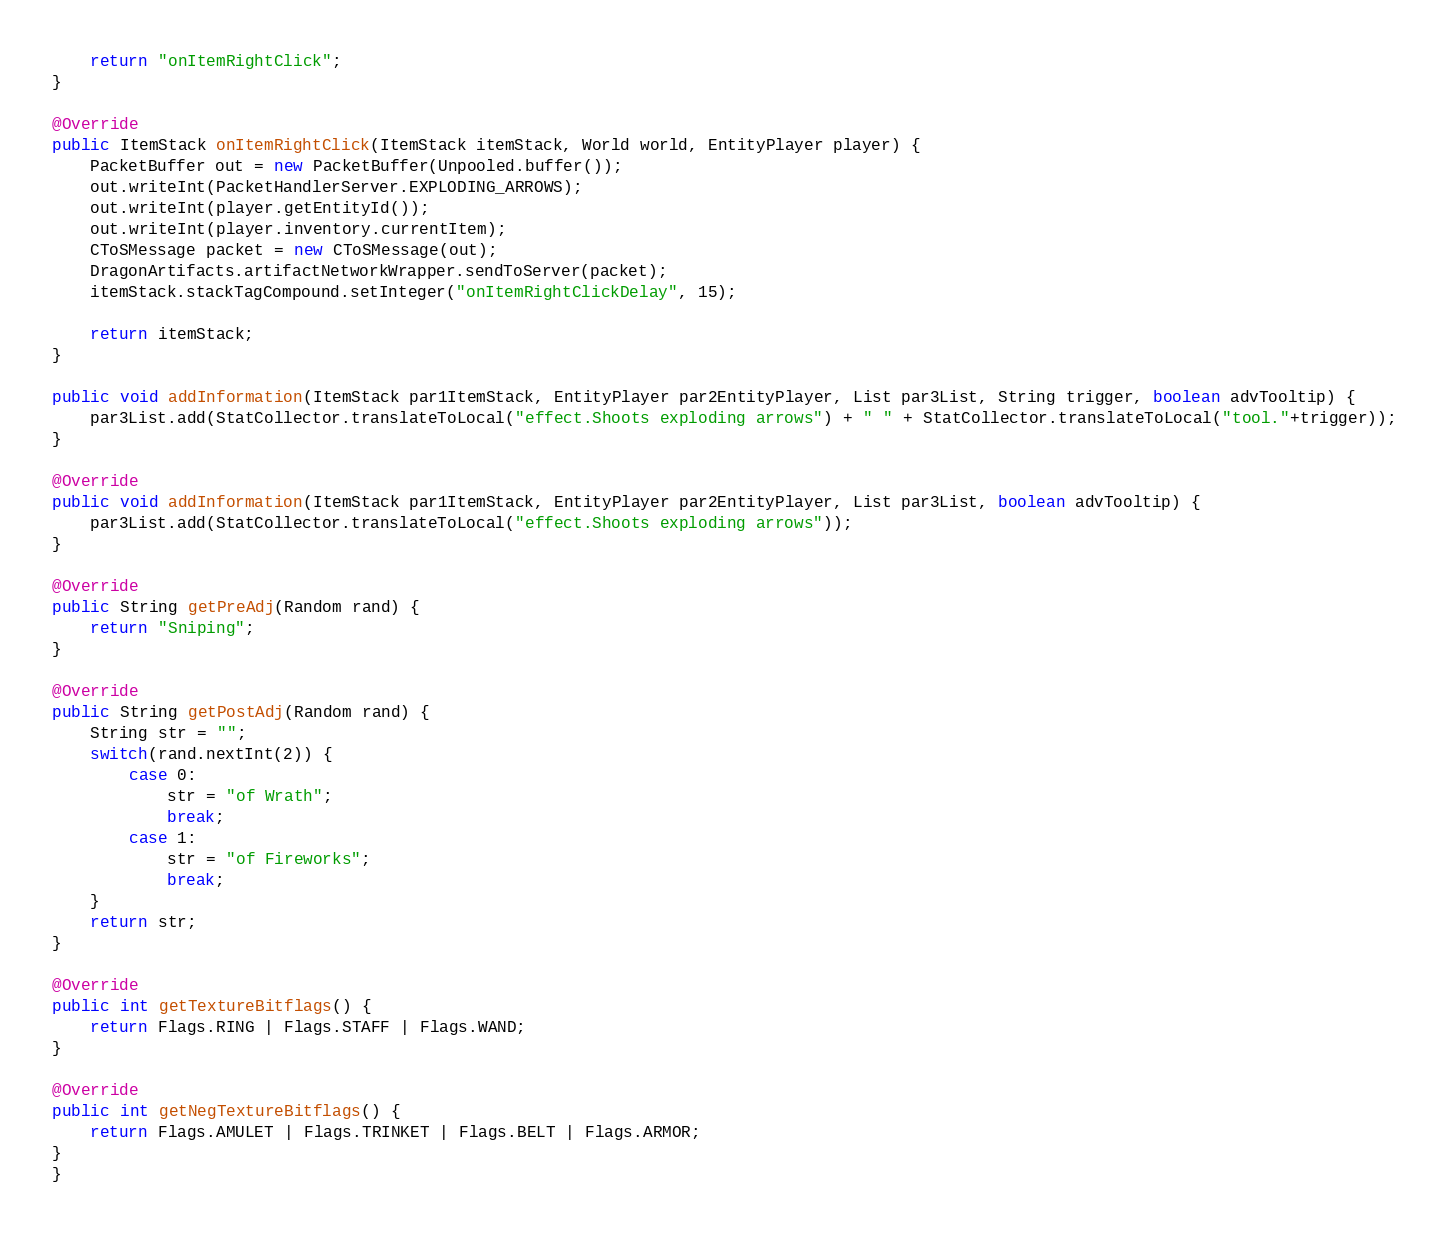<code> <loc_0><loc_0><loc_500><loc_500><_Java_>
	return "onItemRightClick";
}

@Override
public ItemStack onItemRightClick(ItemStack itemStack, World world, EntityPlayer player) {
	PacketBuffer out = new PacketBuffer(Unpooled.buffer());
	out.writeInt(PacketHandlerServer.EXPLODING_ARROWS);
	out.writeInt(player.getEntityId());
	out.writeInt(player.inventory.currentItem);
	CToSMessage packet = new CToSMessage(out);
	DragonArtifacts.artifactNetworkWrapper.sendToServer(packet);
	itemStack.stackTagCompound.setInteger("onItemRightClickDelay", 15);

	return itemStack;
}

public void addInformation(ItemStack par1ItemStack, EntityPlayer par2EntityPlayer, List par3List, String trigger, boolean advTooltip) {
	par3List.add(StatCollector.translateToLocal("effect.Shoots exploding arrows") + " " + StatCollector.translateToLocal("tool."+trigger));
}

@Override
public void addInformation(ItemStack par1ItemStack, EntityPlayer par2EntityPlayer, List par3List, boolean advTooltip) {
	par3List.add(StatCollector.translateToLocal("effect.Shoots exploding arrows"));
}

@Override
public String getPreAdj(Random rand) {
	return "Sniping";
}

@Override
public String getPostAdj(Random rand) {
	String str = "";
	switch(rand.nextInt(2)) {
		case 0:
			str = "of Wrath";
			break;
		case 1:
			str = "of Fireworks";
			break;
	}
	return str;
}

@Override
public int getTextureBitflags() {
	return Flags.RING | Flags.STAFF | Flags.WAND;
}

@Override
public int getNegTextureBitflags() {
	return Flags.AMULET | Flags.TRINKET | Flags.BELT | Flags.ARMOR;
}
}

</code> 